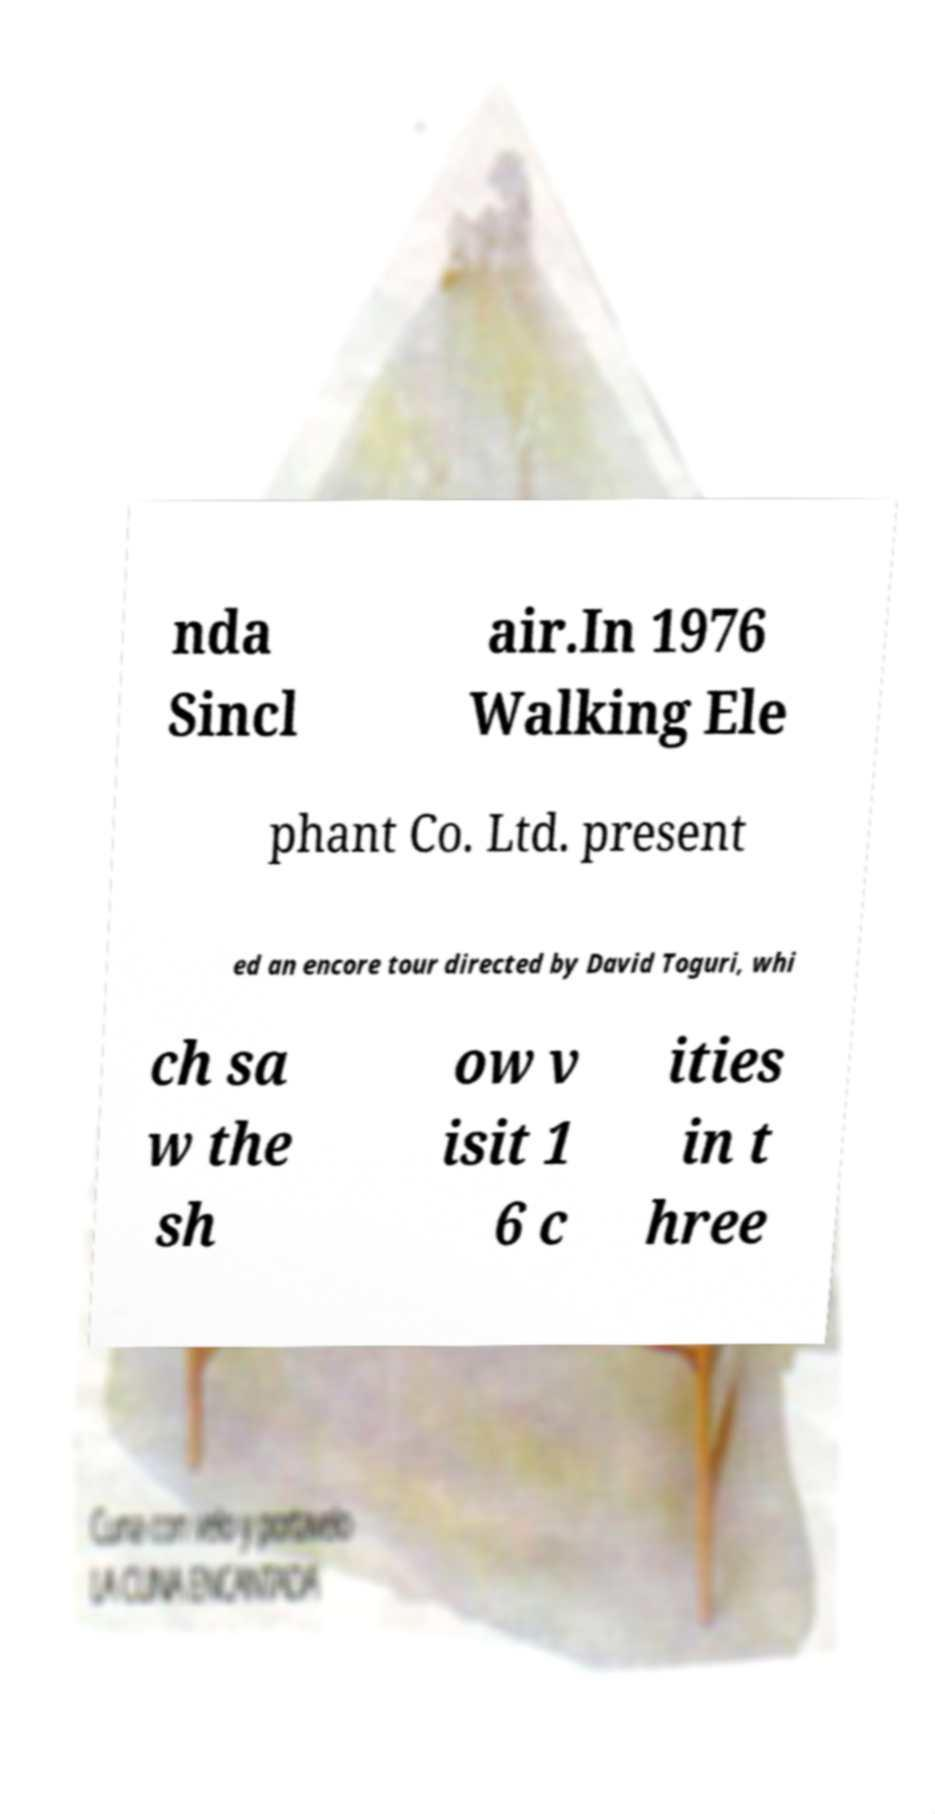For documentation purposes, I need the text within this image transcribed. Could you provide that? nda Sincl air.In 1976 Walking Ele phant Co. Ltd. present ed an encore tour directed by David Toguri, whi ch sa w the sh ow v isit 1 6 c ities in t hree 